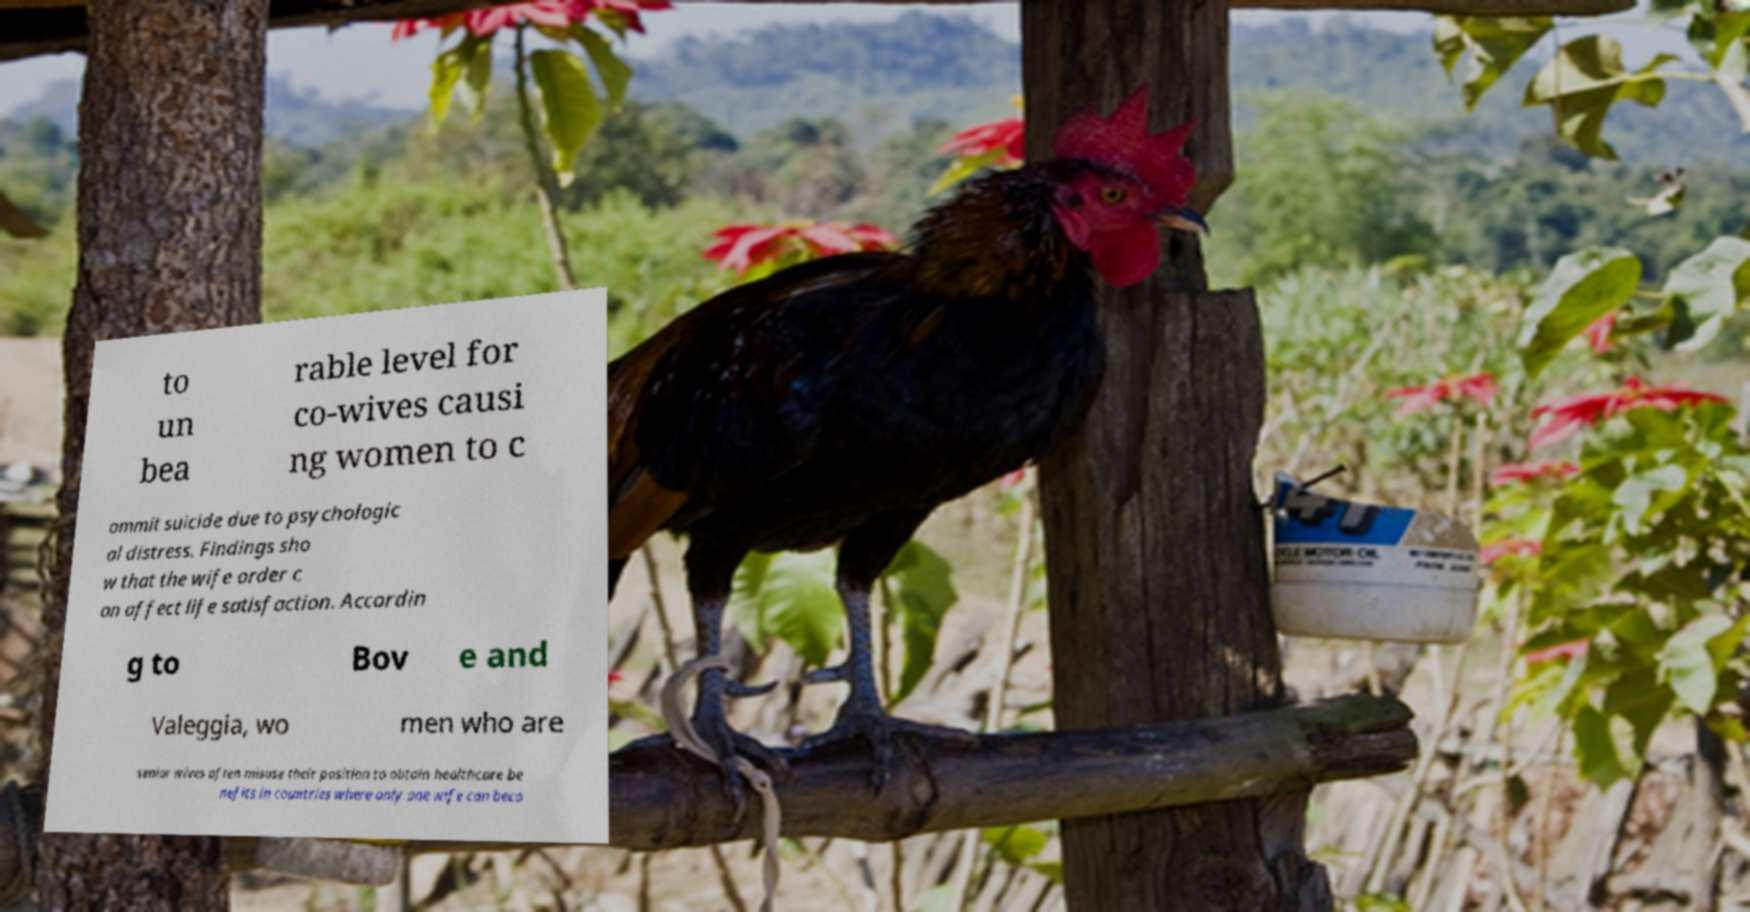Please identify and transcribe the text found in this image. to un bea rable level for co-wives causi ng women to c ommit suicide due to psychologic al distress. Findings sho w that the wife order c an affect life satisfaction. Accordin g to Bov e and Valeggia, wo men who are senior wives often misuse their position to obtain healthcare be nefits in countries where only one wife can beco 